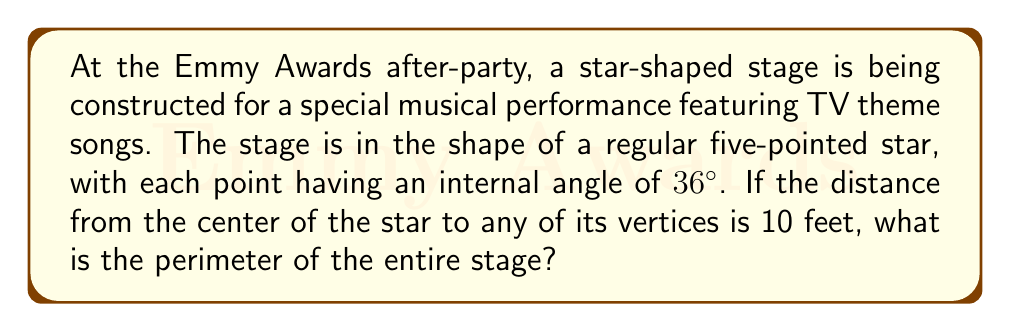Provide a solution to this math problem. Let's approach this step-by-step:

1) In a regular five-pointed star, each point forms an isosceles triangle with the center.

2) The angle at the center of each of these triangles is:
   $$\frac{360°}{5} = 72°$$

3) Since the internal angle at each point is 36°, the base angles of each isosceles triangle are:
   $$\frac{180° - 72° - 36°}{2} = 36°$$

4) Let's focus on one of these isosceles triangles. We know:
   - The length from center to vertex (radius) is 10 feet
   - The angle between two radii is 72°

5) We need to find the length of one side of the star. This is twice the base of our isosceles triangle.

6) In the isosceles triangle, we can use the law of cosines:
   $$a^2 = 2r^2 - 2r^2 \cos \theta$$
   Where $a$ is the side of the star, $r$ is the radius, and $\theta$ is the angle between radii.

7) Plugging in our values:
   $$a^2 = 2(10^2) - 2(10^2) \cos 72°$$
   $$a^2 = 200 - 200 \cos 72°$$
   $$a^2 = 200 - 200 (0.3090) = 138.20$$
   $$a = \sqrt{138.20} \approx 11.7559$$

8) The perimeter is 5 times this length:
   $$\text{Perimeter} = 5 \times 11.7559 \approx 58.7795 \text{ feet}$$

[asy]
import geometry;

unitsize(10cm);

pair A = dir(90);
pair B = dir(90+72);
pair C = dir(90+144);
pair D = dir(90+216);
pair E = dir(90+288);

draw(A--B--C--D--E--cycle);
draw(A--(0,0)--C);
draw(B--(0,0)--D);
draw(E--(0,0));

label("10 ft", (0,0)--A, W);
label("72°", (0,0), NE);

</asy]
Answer: $58.78$ feet 